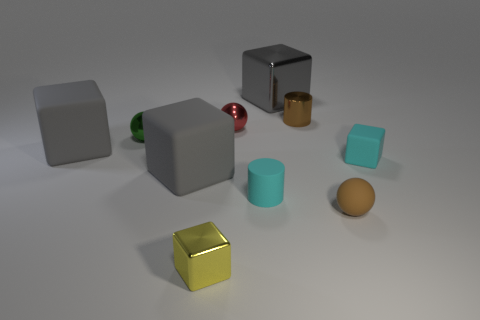Subtract all big blocks. How many blocks are left? 2 Subtract all green balls. How many balls are left? 2 Add 7 tiny brown balls. How many tiny brown balls are left? 8 Add 4 brown metallic objects. How many brown metallic objects exist? 5 Subtract 0 blue cylinders. How many objects are left? 10 Subtract all cylinders. How many objects are left? 8 Subtract 1 cylinders. How many cylinders are left? 1 Subtract all brown cubes. Subtract all purple spheres. How many cubes are left? 5 Subtract all green spheres. How many gray blocks are left? 3 Subtract all large blue shiny things. Subtract all small cyan things. How many objects are left? 8 